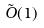<formula> <loc_0><loc_0><loc_500><loc_500>\tilde { O } ( 1 )</formula> 